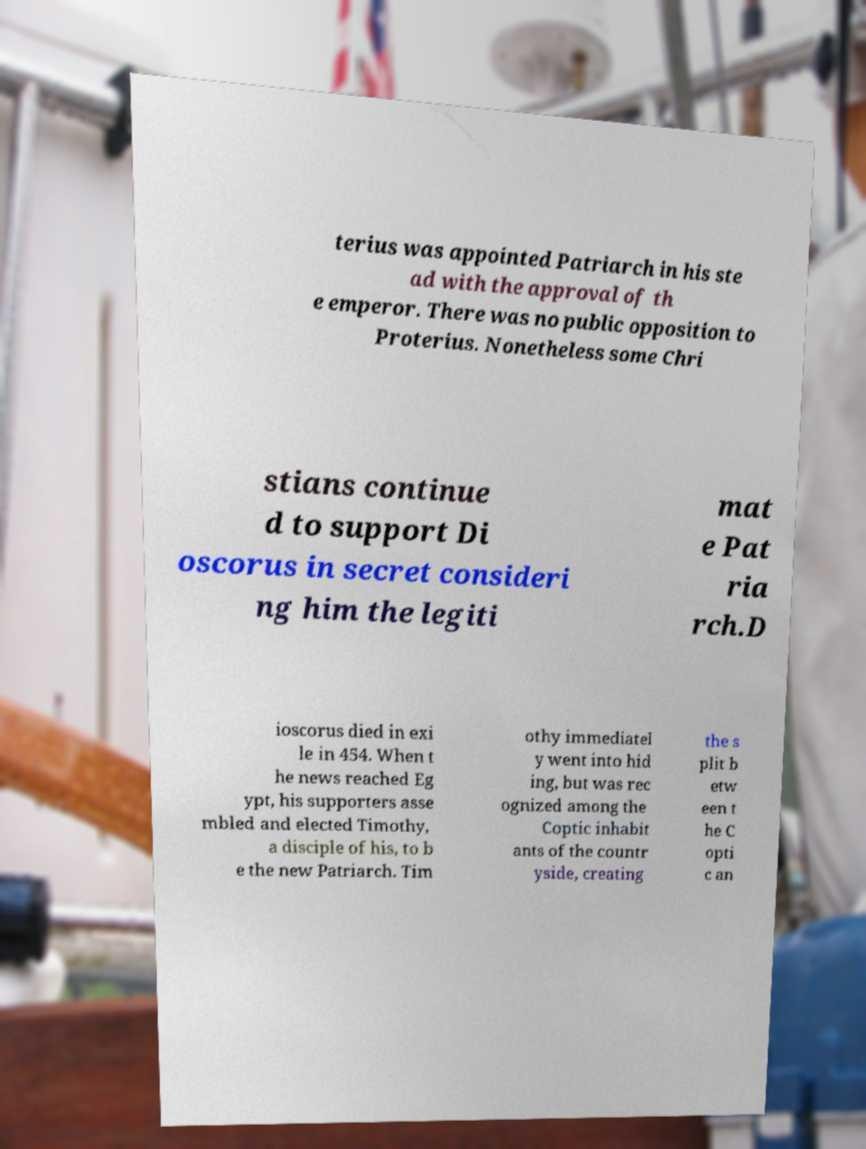Could you extract and type out the text from this image? terius was appointed Patriarch in his ste ad with the approval of th e emperor. There was no public opposition to Proterius. Nonetheless some Chri stians continue d to support Di oscorus in secret consideri ng him the legiti mat e Pat ria rch.D ioscorus died in exi le in 454. When t he news reached Eg ypt, his supporters asse mbled and elected Timothy, a disciple of his, to b e the new Patriarch. Tim othy immediatel y went into hid ing, but was rec ognized among the Coptic inhabit ants of the countr yside, creating the s plit b etw een t he C opti c an 